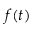<formula> <loc_0><loc_0><loc_500><loc_500>f ( t )</formula> 